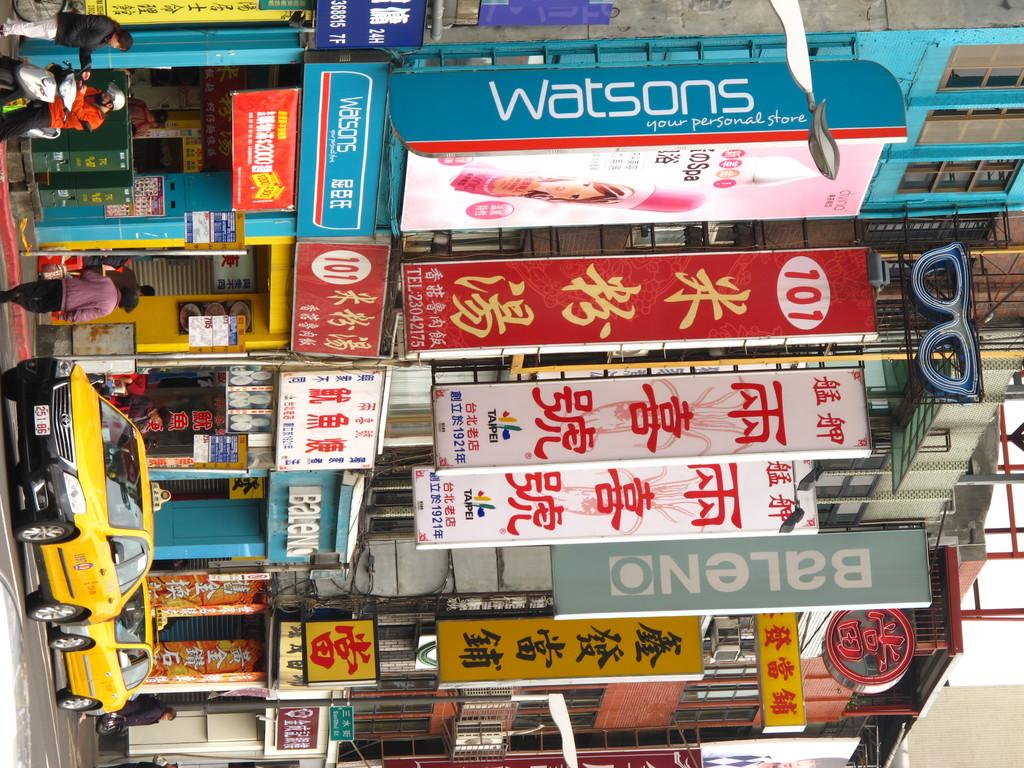<image>
Render a clear and concise summary of the photo. Several Chinese signs including one written in English that says Watsons. 